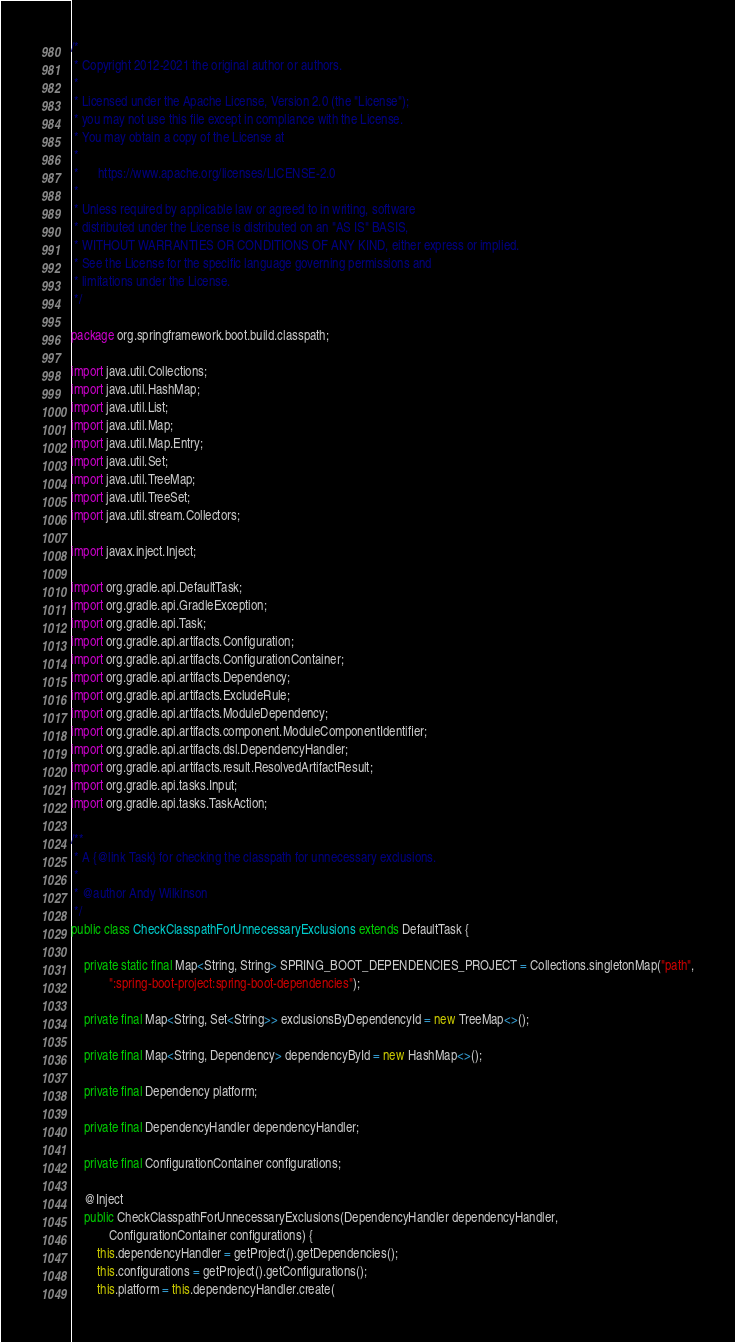Convert code to text. <code><loc_0><loc_0><loc_500><loc_500><_Java_>/*
 * Copyright 2012-2021 the original author or authors.
 *
 * Licensed under the Apache License, Version 2.0 (the "License");
 * you may not use this file except in compliance with the License.
 * You may obtain a copy of the License at
 *
 *      https://www.apache.org/licenses/LICENSE-2.0
 *
 * Unless required by applicable law or agreed to in writing, software
 * distributed under the License is distributed on an "AS IS" BASIS,
 * WITHOUT WARRANTIES OR CONDITIONS OF ANY KIND, either express or implied.
 * See the License for the specific language governing permissions and
 * limitations under the License.
 */

package org.springframework.boot.build.classpath;

import java.util.Collections;
import java.util.HashMap;
import java.util.List;
import java.util.Map;
import java.util.Map.Entry;
import java.util.Set;
import java.util.TreeMap;
import java.util.TreeSet;
import java.util.stream.Collectors;

import javax.inject.Inject;

import org.gradle.api.DefaultTask;
import org.gradle.api.GradleException;
import org.gradle.api.Task;
import org.gradle.api.artifacts.Configuration;
import org.gradle.api.artifacts.ConfigurationContainer;
import org.gradle.api.artifacts.Dependency;
import org.gradle.api.artifacts.ExcludeRule;
import org.gradle.api.artifacts.ModuleDependency;
import org.gradle.api.artifacts.component.ModuleComponentIdentifier;
import org.gradle.api.artifacts.dsl.DependencyHandler;
import org.gradle.api.artifacts.result.ResolvedArtifactResult;
import org.gradle.api.tasks.Input;
import org.gradle.api.tasks.TaskAction;

/**
 * A {@link Task} for checking the classpath for unnecessary exclusions.
 *
 * @author Andy Wilkinson
 */
public class CheckClasspathForUnnecessaryExclusions extends DefaultTask {

	private static final Map<String, String> SPRING_BOOT_DEPENDENCIES_PROJECT = Collections.singletonMap("path",
			":spring-boot-project:spring-boot-dependencies");

	private final Map<String, Set<String>> exclusionsByDependencyId = new TreeMap<>();

	private final Map<String, Dependency> dependencyById = new HashMap<>();

	private final Dependency platform;

	private final DependencyHandler dependencyHandler;

	private final ConfigurationContainer configurations;

	@Inject
	public CheckClasspathForUnnecessaryExclusions(DependencyHandler dependencyHandler,
			ConfigurationContainer configurations) {
		this.dependencyHandler = getProject().getDependencies();
		this.configurations = getProject().getConfigurations();
		this.platform = this.dependencyHandler.create(</code> 